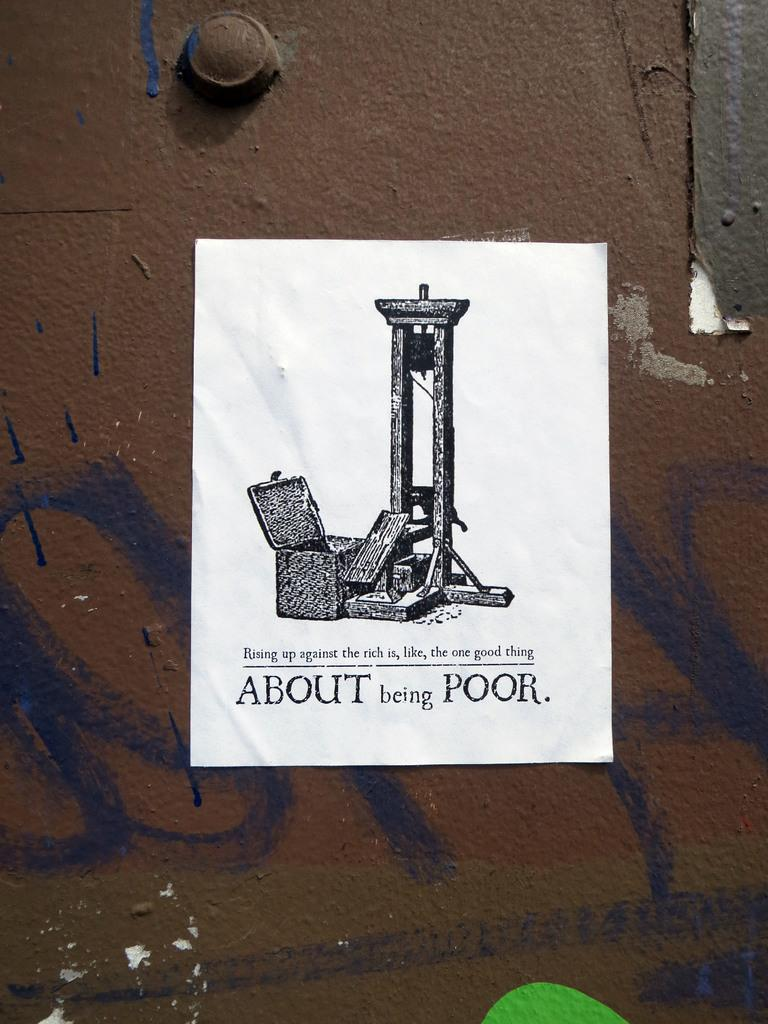<image>
Create a compact narrative representing the image presented. A flyer with a guillotine on it that says About being Poor at the bottom 